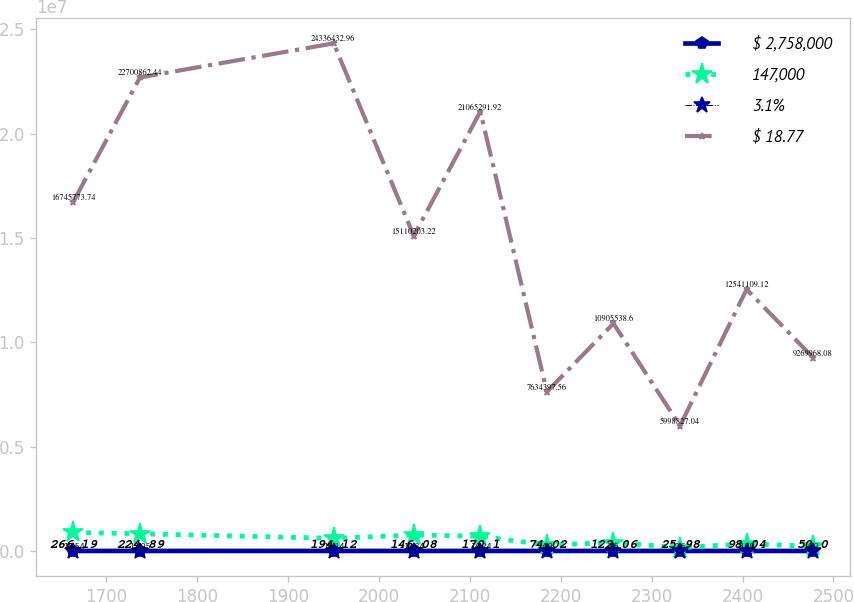Convert chart. <chart><loc_0><loc_0><loc_500><loc_500><line_chart><ecel><fcel>$ 2,758,000<fcel>147,000<fcel>3.1%<fcel>$ 18.77<nl><fcel>1663.56<fcel>266.19<fcel>885954<fcel>15.54<fcel>1.67458e+07<nl><fcel>1736.81<fcel>224.89<fcel>825571<fcel>12.95<fcel>2.27009e+07<nl><fcel>1950.01<fcel>194.12<fcel>605249<fcel>18.14<fcel>2.43364e+07<nl><fcel>2038.15<fcel>146.08<fcel>765188<fcel>16.84<fcel>1.51102e+07<nl><fcel>2111.39<fcel>170.1<fcel>704805<fcel>14.24<fcel>2.10653e+07<nl><fcel>2184.63<fcel>74.02<fcel>281887<fcel>4.9<fcel>7.6344e+06<nl><fcel>2257.88<fcel>122.06<fcel>402653<fcel>7.5<fcel>1.09055e+07<nl><fcel>2331.12<fcel>25.98<fcel>161122<fcel>3.6<fcel>5.99883e+06<nl><fcel>2404.36<fcel>98.04<fcel>342270<fcel>8.79<fcel>1.25411e+07<nl><fcel>2477.61<fcel>50<fcel>221504<fcel>6.2<fcel>9.26997e+06<nl></chart> 